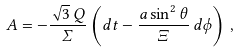Convert formula to latex. <formula><loc_0><loc_0><loc_500><loc_500>A = - \frac { \sqrt { 3 } \, Q } { \Sigma } \left ( d t - \frac { a \sin ^ { 2 } \theta } { \Xi } \, d \phi \right ) \, ,</formula> 